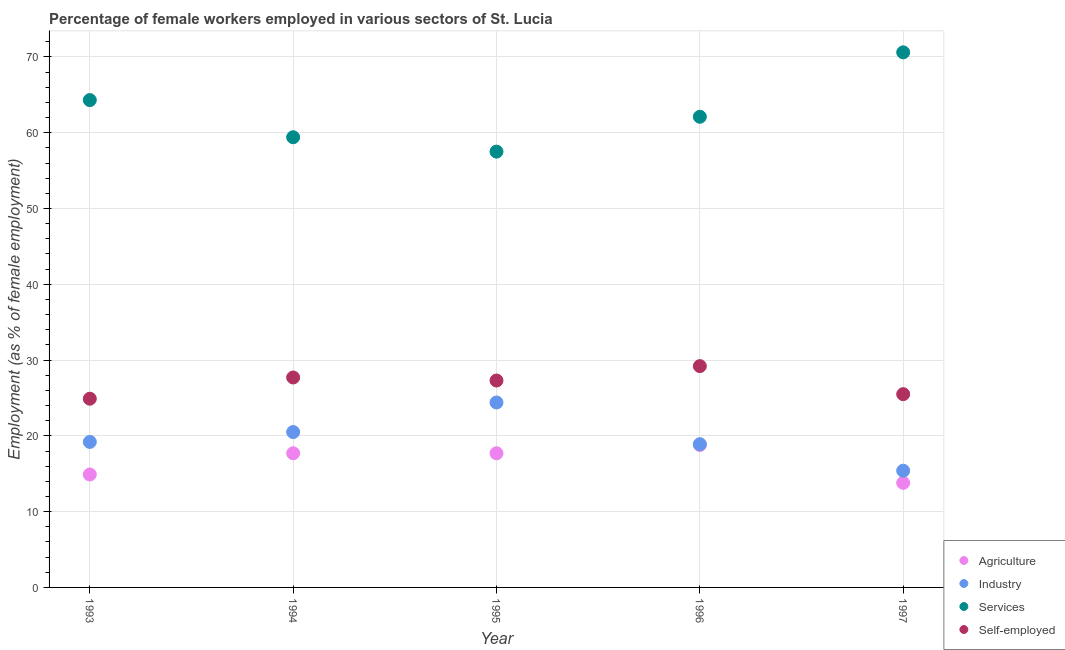Is the number of dotlines equal to the number of legend labels?
Make the answer very short. Yes. What is the percentage of female workers in industry in 1997?
Provide a succinct answer. 15.4. Across all years, what is the maximum percentage of female workers in agriculture?
Ensure brevity in your answer.  18.8. Across all years, what is the minimum percentage of self employed female workers?
Your answer should be very brief. 24.9. In which year was the percentage of female workers in services maximum?
Provide a short and direct response. 1997. What is the total percentage of self employed female workers in the graph?
Make the answer very short. 134.6. What is the difference between the percentage of female workers in services in 1996 and that in 1997?
Keep it short and to the point. -8.5. What is the difference between the percentage of female workers in services in 1993 and the percentage of female workers in industry in 1995?
Provide a succinct answer. 39.9. What is the average percentage of female workers in agriculture per year?
Provide a short and direct response. 16.58. In the year 1993, what is the difference between the percentage of self employed female workers and percentage of female workers in agriculture?
Your response must be concise. 10. What is the ratio of the percentage of female workers in agriculture in 1993 to that in 1997?
Offer a very short reply. 1.08. What is the difference between the highest and the second highest percentage of female workers in industry?
Your answer should be very brief. 3.9. What is the difference between the highest and the lowest percentage of self employed female workers?
Offer a very short reply. 4.3. In how many years, is the percentage of female workers in agriculture greater than the average percentage of female workers in agriculture taken over all years?
Give a very brief answer. 3. Is it the case that in every year, the sum of the percentage of female workers in agriculture and percentage of female workers in industry is greater than the percentage of female workers in services?
Make the answer very short. No. Does the percentage of female workers in industry monotonically increase over the years?
Your answer should be very brief. No. Is the percentage of self employed female workers strictly greater than the percentage of female workers in services over the years?
Offer a very short reply. No. Is the percentage of self employed female workers strictly less than the percentage of female workers in services over the years?
Ensure brevity in your answer.  Yes. How many dotlines are there?
Keep it short and to the point. 4. Are the values on the major ticks of Y-axis written in scientific E-notation?
Provide a succinct answer. No. Does the graph contain grids?
Your answer should be very brief. Yes. How many legend labels are there?
Provide a short and direct response. 4. What is the title of the graph?
Give a very brief answer. Percentage of female workers employed in various sectors of St. Lucia. Does "Other expenses" appear as one of the legend labels in the graph?
Offer a terse response. No. What is the label or title of the Y-axis?
Ensure brevity in your answer.  Employment (as % of female employment). What is the Employment (as % of female employment) in Agriculture in 1993?
Offer a terse response. 14.9. What is the Employment (as % of female employment) of Industry in 1993?
Provide a short and direct response. 19.2. What is the Employment (as % of female employment) of Services in 1993?
Give a very brief answer. 64.3. What is the Employment (as % of female employment) in Self-employed in 1993?
Your response must be concise. 24.9. What is the Employment (as % of female employment) of Agriculture in 1994?
Offer a terse response. 17.7. What is the Employment (as % of female employment) in Services in 1994?
Your response must be concise. 59.4. What is the Employment (as % of female employment) in Self-employed in 1994?
Offer a terse response. 27.7. What is the Employment (as % of female employment) in Agriculture in 1995?
Ensure brevity in your answer.  17.7. What is the Employment (as % of female employment) in Industry in 1995?
Your answer should be very brief. 24.4. What is the Employment (as % of female employment) in Services in 1995?
Keep it short and to the point. 57.5. What is the Employment (as % of female employment) in Self-employed in 1995?
Your response must be concise. 27.3. What is the Employment (as % of female employment) of Agriculture in 1996?
Your answer should be very brief. 18.8. What is the Employment (as % of female employment) in Industry in 1996?
Provide a succinct answer. 18.9. What is the Employment (as % of female employment) in Services in 1996?
Keep it short and to the point. 62.1. What is the Employment (as % of female employment) of Self-employed in 1996?
Your answer should be compact. 29.2. What is the Employment (as % of female employment) of Agriculture in 1997?
Offer a terse response. 13.8. What is the Employment (as % of female employment) in Industry in 1997?
Offer a terse response. 15.4. What is the Employment (as % of female employment) of Services in 1997?
Your answer should be compact. 70.6. What is the Employment (as % of female employment) in Self-employed in 1997?
Make the answer very short. 25.5. Across all years, what is the maximum Employment (as % of female employment) in Agriculture?
Provide a short and direct response. 18.8. Across all years, what is the maximum Employment (as % of female employment) in Industry?
Keep it short and to the point. 24.4. Across all years, what is the maximum Employment (as % of female employment) of Services?
Give a very brief answer. 70.6. Across all years, what is the maximum Employment (as % of female employment) of Self-employed?
Ensure brevity in your answer.  29.2. Across all years, what is the minimum Employment (as % of female employment) of Agriculture?
Give a very brief answer. 13.8. Across all years, what is the minimum Employment (as % of female employment) in Industry?
Offer a very short reply. 15.4. Across all years, what is the minimum Employment (as % of female employment) of Services?
Your answer should be very brief. 57.5. Across all years, what is the minimum Employment (as % of female employment) in Self-employed?
Your answer should be very brief. 24.9. What is the total Employment (as % of female employment) of Agriculture in the graph?
Give a very brief answer. 82.9. What is the total Employment (as % of female employment) of Industry in the graph?
Your answer should be compact. 98.4. What is the total Employment (as % of female employment) of Services in the graph?
Ensure brevity in your answer.  313.9. What is the total Employment (as % of female employment) in Self-employed in the graph?
Provide a short and direct response. 134.6. What is the difference between the Employment (as % of female employment) in Industry in 1993 and that in 1994?
Offer a very short reply. -1.3. What is the difference between the Employment (as % of female employment) of Services in 1993 and that in 1994?
Ensure brevity in your answer.  4.9. What is the difference between the Employment (as % of female employment) in Agriculture in 1993 and that in 1995?
Offer a very short reply. -2.8. What is the difference between the Employment (as % of female employment) of Self-employed in 1993 and that in 1995?
Make the answer very short. -2.4. What is the difference between the Employment (as % of female employment) in Agriculture in 1993 and that in 1997?
Provide a short and direct response. 1.1. What is the difference between the Employment (as % of female employment) in Industry in 1993 and that in 1997?
Your answer should be compact. 3.8. What is the difference between the Employment (as % of female employment) in Agriculture in 1994 and that in 1995?
Provide a succinct answer. 0. What is the difference between the Employment (as % of female employment) in Services in 1994 and that in 1995?
Provide a short and direct response. 1.9. What is the difference between the Employment (as % of female employment) of Industry in 1994 and that in 1996?
Offer a terse response. 1.6. What is the difference between the Employment (as % of female employment) of Services in 1994 and that in 1997?
Provide a short and direct response. -11.2. What is the difference between the Employment (as % of female employment) of Agriculture in 1995 and that in 1996?
Your answer should be compact. -1.1. What is the difference between the Employment (as % of female employment) in Industry in 1995 and that in 1996?
Offer a terse response. 5.5. What is the difference between the Employment (as % of female employment) of Agriculture in 1996 and that in 1997?
Make the answer very short. 5. What is the difference between the Employment (as % of female employment) of Services in 1996 and that in 1997?
Make the answer very short. -8.5. What is the difference between the Employment (as % of female employment) in Agriculture in 1993 and the Employment (as % of female employment) in Industry in 1994?
Keep it short and to the point. -5.6. What is the difference between the Employment (as % of female employment) in Agriculture in 1993 and the Employment (as % of female employment) in Services in 1994?
Your response must be concise. -44.5. What is the difference between the Employment (as % of female employment) of Industry in 1993 and the Employment (as % of female employment) of Services in 1994?
Keep it short and to the point. -40.2. What is the difference between the Employment (as % of female employment) of Industry in 1993 and the Employment (as % of female employment) of Self-employed in 1994?
Your response must be concise. -8.5. What is the difference between the Employment (as % of female employment) in Services in 1993 and the Employment (as % of female employment) in Self-employed in 1994?
Keep it short and to the point. 36.6. What is the difference between the Employment (as % of female employment) in Agriculture in 1993 and the Employment (as % of female employment) in Services in 1995?
Your response must be concise. -42.6. What is the difference between the Employment (as % of female employment) in Industry in 1993 and the Employment (as % of female employment) in Services in 1995?
Offer a very short reply. -38.3. What is the difference between the Employment (as % of female employment) of Industry in 1993 and the Employment (as % of female employment) of Self-employed in 1995?
Offer a terse response. -8.1. What is the difference between the Employment (as % of female employment) in Services in 1993 and the Employment (as % of female employment) in Self-employed in 1995?
Your answer should be very brief. 37. What is the difference between the Employment (as % of female employment) of Agriculture in 1993 and the Employment (as % of female employment) of Services in 1996?
Your answer should be compact. -47.2. What is the difference between the Employment (as % of female employment) of Agriculture in 1993 and the Employment (as % of female employment) of Self-employed in 1996?
Give a very brief answer. -14.3. What is the difference between the Employment (as % of female employment) in Industry in 1993 and the Employment (as % of female employment) in Services in 1996?
Offer a very short reply. -42.9. What is the difference between the Employment (as % of female employment) in Services in 1993 and the Employment (as % of female employment) in Self-employed in 1996?
Offer a terse response. 35.1. What is the difference between the Employment (as % of female employment) in Agriculture in 1993 and the Employment (as % of female employment) in Industry in 1997?
Keep it short and to the point. -0.5. What is the difference between the Employment (as % of female employment) of Agriculture in 1993 and the Employment (as % of female employment) of Services in 1997?
Ensure brevity in your answer.  -55.7. What is the difference between the Employment (as % of female employment) in Agriculture in 1993 and the Employment (as % of female employment) in Self-employed in 1997?
Give a very brief answer. -10.6. What is the difference between the Employment (as % of female employment) in Industry in 1993 and the Employment (as % of female employment) in Services in 1997?
Provide a succinct answer. -51.4. What is the difference between the Employment (as % of female employment) in Industry in 1993 and the Employment (as % of female employment) in Self-employed in 1997?
Offer a terse response. -6.3. What is the difference between the Employment (as % of female employment) in Services in 1993 and the Employment (as % of female employment) in Self-employed in 1997?
Keep it short and to the point. 38.8. What is the difference between the Employment (as % of female employment) in Agriculture in 1994 and the Employment (as % of female employment) in Services in 1995?
Provide a succinct answer. -39.8. What is the difference between the Employment (as % of female employment) in Industry in 1994 and the Employment (as % of female employment) in Services in 1995?
Offer a terse response. -37. What is the difference between the Employment (as % of female employment) in Industry in 1994 and the Employment (as % of female employment) in Self-employed in 1995?
Ensure brevity in your answer.  -6.8. What is the difference between the Employment (as % of female employment) in Services in 1994 and the Employment (as % of female employment) in Self-employed in 1995?
Your response must be concise. 32.1. What is the difference between the Employment (as % of female employment) in Agriculture in 1994 and the Employment (as % of female employment) in Industry in 1996?
Your answer should be compact. -1.2. What is the difference between the Employment (as % of female employment) in Agriculture in 1994 and the Employment (as % of female employment) in Services in 1996?
Keep it short and to the point. -44.4. What is the difference between the Employment (as % of female employment) of Industry in 1994 and the Employment (as % of female employment) of Services in 1996?
Provide a succinct answer. -41.6. What is the difference between the Employment (as % of female employment) in Industry in 1994 and the Employment (as % of female employment) in Self-employed in 1996?
Give a very brief answer. -8.7. What is the difference between the Employment (as % of female employment) of Services in 1994 and the Employment (as % of female employment) of Self-employed in 1996?
Make the answer very short. 30.2. What is the difference between the Employment (as % of female employment) in Agriculture in 1994 and the Employment (as % of female employment) in Services in 1997?
Your answer should be compact. -52.9. What is the difference between the Employment (as % of female employment) of Industry in 1994 and the Employment (as % of female employment) of Services in 1997?
Provide a short and direct response. -50.1. What is the difference between the Employment (as % of female employment) in Services in 1994 and the Employment (as % of female employment) in Self-employed in 1997?
Provide a succinct answer. 33.9. What is the difference between the Employment (as % of female employment) of Agriculture in 1995 and the Employment (as % of female employment) of Industry in 1996?
Give a very brief answer. -1.2. What is the difference between the Employment (as % of female employment) of Agriculture in 1995 and the Employment (as % of female employment) of Services in 1996?
Give a very brief answer. -44.4. What is the difference between the Employment (as % of female employment) in Industry in 1995 and the Employment (as % of female employment) in Services in 1996?
Give a very brief answer. -37.7. What is the difference between the Employment (as % of female employment) of Services in 1995 and the Employment (as % of female employment) of Self-employed in 1996?
Offer a very short reply. 28.3. What is the difference between the Employment (as % of female employment) in Agriculture in 1995 and the Employment (as % of female employment) in Services in 1997?
Ensure brevity in your answer.  -52.9. What is the difference between the Employment (as % of female employment) of Industry in 1995 and the Employment (as % of female employment) of Services in 1997?
Ensure brevity in your answer.  -46.2. What is the difference between the Employment (as % of female employment) in Industry in 1995 and the Employment (as % of female employment) in Self-employed in 1997?
Offer a very short reply. -1.1. What is the difference between the Employment (as % of female employment) in Services in 1995 and the Employment (as % of female employment) in Self-employed in 1997?
Provide a succinct answer. 32. What is the difference between the Employment (as % of female employment) in Agriculture in 1996 and the Employment (as % of female employment) in Services in 1997?
Provide a short and direct response. -51.8. What is the difference between the Employment (as % of female employment) in Industry in 1996 and the Employment (as % of female employment) in Services in 1997?
Your answer should be compact. -51.7. What is the difference between the Employment (as % of female employment) of Industry in 1996 and the Employment (as % of female employment) of Self-employed in 1997?
Keep it short and to the point. -6.6. What is the difference between the Employment (as % of female employment) of Services in 1996 and the Employment (as % of female employment) of Self-employed in 1997?
Give a very brief answer. 36.6. What is the average Employment (as % of female employment) in Agriculture per year?
Keep it short and to the point. 16.58. What is the average Employment (as % of female employment) of Industry per year?
Your answer should be compact. 19.68. What is the average Employment (as % of female employment) of Services per year?
Offer a terse response. 62.78. What is the average Employment (as % of female employment) in Self-employed per year?
Your response must be concise. 26.92. In the year 1993, what is the difference between the Employment (as % of female employment) in Agriculture and Employment (as % of female employment) in Services?
Give a very brief answer. -49.4. In the year 1993, what is the difference between the Employment (as % of female employment) in Industry and Employment (as % of female employment) in Services?
Keep it short and to the point. -45.1. In the year 1993, what is the difference between the Employment (as % of female employment) of Services and Employment (as % of female employment) of Self-employed?
Keep it short and to the point. 39.4. In the year 1994, what is the difference between the Employment (as % of female employment) in Agriculture and Employment (as % of female employment) in Industry?
Your answer should be very brief. -2.8. In the year 1994, what is the difference between the Employment (as % of female employment) in Agriculture and Employment (as % of female employment) in Services?
Your answer should be compact. -41.7. In the year 1994, what is the difference between the Employment (as % of female employment) of Industry and Employment (as % of female employment) of Services?
Your response must be concise. -38.9. In the year 1994, what is the difference between the Employment (as % of female employment) of Services and Employment (as % of female employment) of Self-employed?
Keep it short and to the point. 31.7. In the year 1995, what is the difference between the Employment (as % of female employment) in Agriculture and Employment (as % of female employment) in Industry?
Offer a terse response. -6.7. In the year 1995, what is the difference between the Employment (as % of female employment) in Agriculture and Employment (as % of female employment) in Services?
Provide a short and direct response. -39.8. In the year 1995, what is the difference between the Employment (as % of female employment) in Industry and Employment (as % of female employment) in Services?
Keep it short and to the point. -33.1. In the year 1995, what is the difference between the Employment (as % of female employment) of Industry and Employment (as % of female employment) of Self-employed?
Keep it short and to the point. -2.9. In the year 1995, what is the difference between the Employment (as % of female employment) of Services and Employment (as % of female employment) of Self-employed?
Give a very brief answer. 30.2. In the year 1996, what is the difference between the Employment (as % of female employment) of Agriculture and Employment (as % of female employment) of Services?
Offer a very short reply. -43.3. In the year 1996, what is the difference between the Employment (as % of female employment) in Industry and Employment (as % of female employment) in Services?
Keep it short and to the point. -43.2. In the year 1996, what is the difference between the Employment (as % of female employment) in Industry and Employment (as % of female employment) in Self-employed?
Offer a terse response. -10.3. In the year 1996, what is the difference between the Employment (as % of female employment) in Services and Employment (as % of female employment) in Self-employed?
Keep it short and to the point. 32.9. In the year 1997, what is the difference between the Employment (as % of female employment) of Agriculture and Employment (as % of female employment) of Industry?
Provide a succinct answer. -1.6. In the year 1997, what is the difference between the Employment (as % of female employment) of Agriculture and Employment (as % of female employment) of Services?
Your answer should be compact. -56.8. In the year 1997, what is the difference between the Employment (as % of female employment) in Industry and Employment (as % of female employment) in Services?
Provide a short and direct response. -55.2. In the year 1997, what is the difference between the Employment (as % of female employment) in Services and Employment (as % of female employment) in Self-employed?
Keep it short and to the point. 45.1. What is the ratio of the Employment (as % of female employment) in Agriculture in 1993 to that in 1994?
Provide a succinct answer. 0.84. What is the ratio of the Employment (as % of female employment) of Industry in 1993 to that in 1994?
Provide a succinct answer. 0.94. What is the ratio of the Employment (as % of female employment) in Services in 1993 to that in 1994?
Offer a terse response. 1.08. What is the ratio of the Employment (as % of female employment) in Self-employed in 1993 to that in 1994?
Make the answer very short. 0.9. What is the ratio of the Employment (as % of female employment) of Agriculture in 1993 to that in 1995?
Your response must be concise. 0.84. What is the ratio of the Employment (as % of female employment) in Industry in 1993 to that in 1995?
Keep it short and to the point. 0.79. What is the ratio of the Employment (as % of female employment) of Services in 1993 to that in 1995?
Offer a terse response. 1.12. What is the ratio of the Employment (as % of female employment) of Self-employed in 1993 to that in 1995?
Your response must be concise. 0.91. What is the ratio of the Employment (as % of female employment) of Agriculture in 1993 to that in 1996?
Keep it short and to the point. 0.79. What is the ratio of the Employment (as % of female employment) in Industry in 1993 to that in 1996?
Make the answer very short. 1.02. What is the ratio of the Employment (as % of female employment) of Services in 1993 to that in 1996?
Provide a short and direct response. 1.04. What is the ratio of the Employment (as % of female employment) in Self-employed in 1993 to that in 1996?
Your response must be concise. 0.85. What is the ratio of the Employment (as % of female employment) in Agriculture in 1993 to that in 1997?
Give a very brief answer. 1.08. What is the ratio of the Employment (as % of female employment) of Industry in 1993 to that in 1997?
Your response must be concise. 1.25. What is the ratio of the Employment (as % of female employment) in Services in 1993 to that in 1997?
Make the answer very short. 0.91. What is the ratio of the Employment (as % of female employment) of Self-employed in 1993 to that in 1997?
Offer a terse response. 0.98. What is the ratio of the Employment (as % of female employment) in Agriculture in 1994 to that in 1995?
Offer a very short reply. 1. What is the ratio of the Employment (as % of female employment) of Industry in 1994 to that in 1995?
Your answer should be compact. 0.84. What is the ratio of the Employment (as % of female employment) in Services in 1994 to that in 1995?
Give a very brief answer. 1.03. What is the ratio of the Employment (as % of female employment) of Self-employed in 1994 to that in 1995?
Your answer should be very brief. 1.01. What is the ratio of the Employment (as % of female employment) in Agriculture in 1994 to that in 1996?
Provide a short and direct response. 0.94. What is the ratio of the Employment (as % of female employment) of Industry in 1994 to that in 1996?
Provide a short and direct response. 1.08. What is the ratio of the Employment (as % of female employment) of Services in 1994 to that in 1996?
Make the answer very short. 0.96. What is the ratio of the Employment (as % of female employment) of Self-employed in 1994 to that in 1996?
Offer a terse response. 0.95. What is the ratio of the Employment (as % of female employment) in Agriculture in 1994 to that in 1997?
Your response must be concise. 1.28. What is the ratio of the Employment (as % of female employment) of Industry in 1994 to that in 1997?
Offer a very short reply. 1.33. What is the ratio of the Employment (as % of female employment) of Services in 1994 to that in 1997?
Give a very brief answer. 0.84. What is the ratio of the Employment (as % of female employment) of Self-employed in 1994 to that in 1997?
Keep it short and to the point. 1.09. What is the ratio of the Employment (as % of female employment) of Agriculture in 1995 to that in 1996?
Provide a short and direct response. 0.94. What is the ratio of the Employment (as % of female employment) in Industry in 1995 to that in 1996?
Offer a terse response. 1.29. What is the ratio of the Employment (as % of female employment) in Services in 1995 to that in 1996?
Provide a short and direct response. 0.93. What is the ratio of the Employment (as % of female employment) in Self-employed in 1995 to that in 1996?
Provide a short and direct response. 0.93. What is the ratio of the Employment (as % of female employment) of Agriculture in 1995 to that in 1997?
Keep it short and to the point. 1.28. What is the ratio of the Employment (as % of female employment) in Industry in 1995 to that in 1997?
Keep it short and to the point. 1.58. What is the ratio of the Employment (as % of female employment) in Services in 1995 to that in 1997?
Your response must be concise. 0.81. What is the ratio of the Employment (as % of female employment) in Self-employed in 1995 to that in 1997?
Your answer should be compact. 1.07. What is the ratio of the Employment (as % of female employment) of Agriculture in 1996 to that in 1997?
Your answer should be very brief. 1.36. What is the ratio of the Employment (as % of female employment) of Industry in 1996 to that in 1997?
Offer a terse response. 1.23. What is the ratio of the Employment (as % of female employment) in Services in 1996 to that in 1997?
Your answer should be compact. 0.88. What is the ratio of the Employment (as % of female employment) in Self-employed in 1996 to that in 1997?
Your answer should be compact. 1.15. What is the difference between the highest and the second highest Employment (as % of female employment) of Industry?
Offer a terse response. 3.9. What is the difference between the highest and the second highest Employment (as % of female employment) of Services?
Your answer should be compact. 6.3. What is the difference between the highest and the second highest Employment (as % of female employment) in Self-employed?
Your answer should be compact. 1.5. What is the difference between the highest and the lowest Employment (as % of female employment) in Agriculture?
Ensure brevity in your answer.  5. What is the difference between the highest and the lowest Employment (as % of female employment) of Industry?
Offer a terse response. 9. What is the difference between the highest and the lowest Employment (as % of female employment) in Services?
Ensure brevity in your answer.  13.1. 